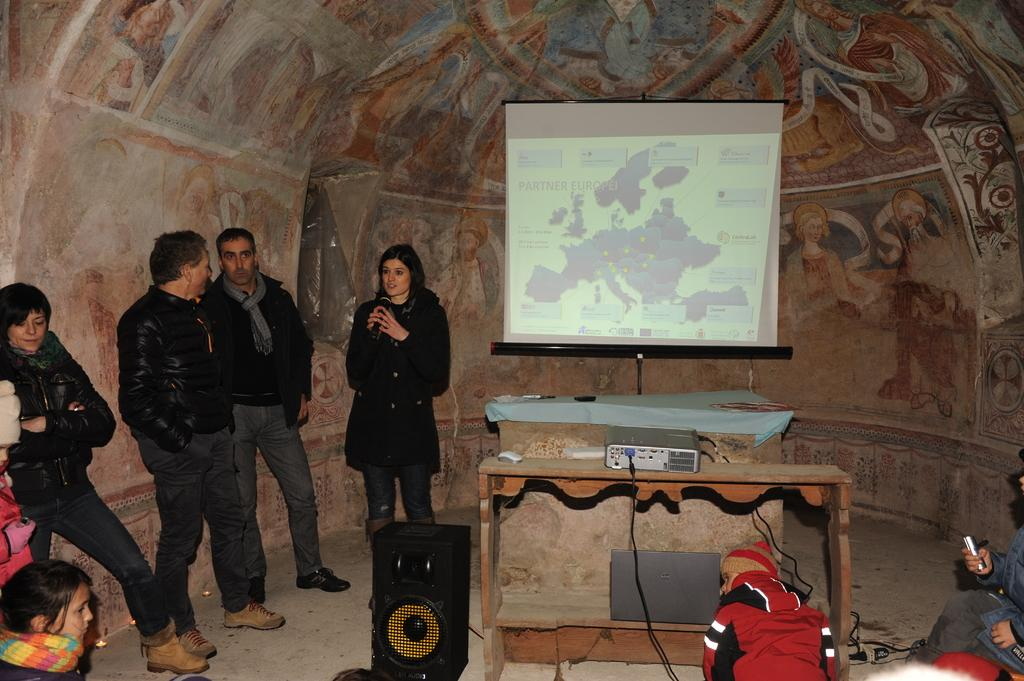What is happening in the image? There are people standing in the image, and they are likely gathered around a projector display. What is the main focus of the gathering? The main focus is the projector display in the center of the image. What is placed on the table in front of the projector display? A table is present in front of the projector display, and the projector is placed on it. What is used to amplify sound in the image? There is a speaker to the left of the projector display, which is used to amplify sound. What type of cloth is being used to cover the people's toes in the image? There is no cloth covering anyone's toes in the image. What meal is being served on the table in the image? There is no meal present on the table in the image; it is occupied by the projector. 